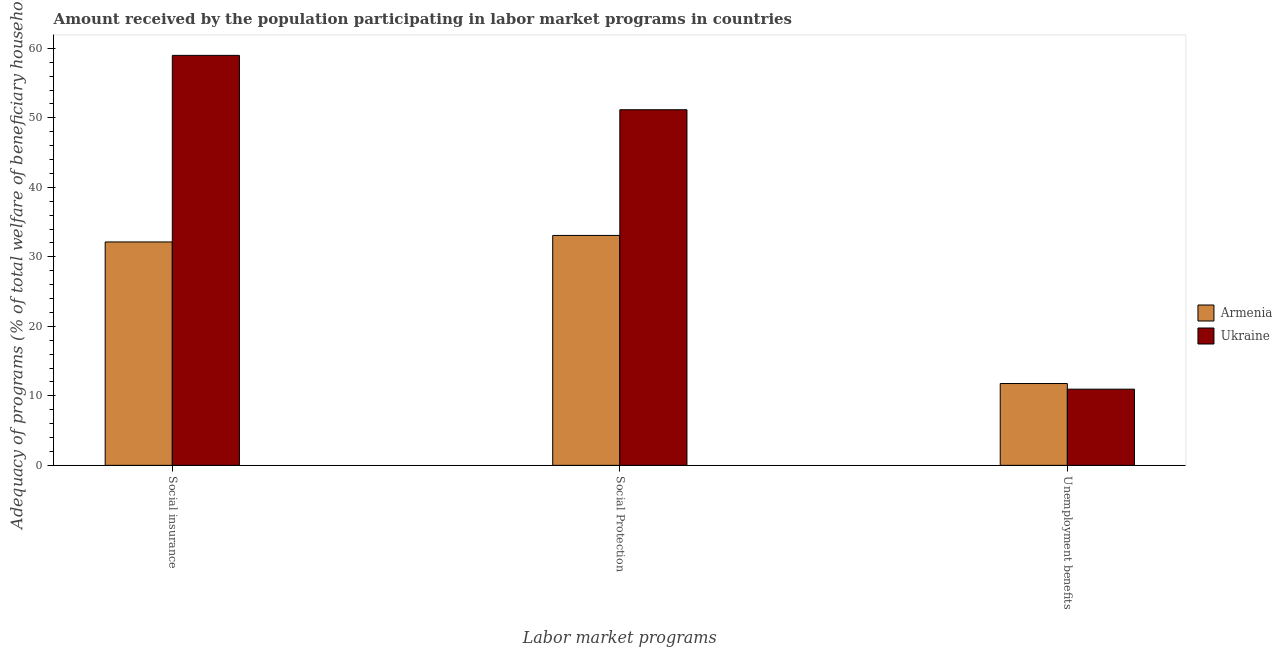How many different coloured bars are there?
Ensure brevity in your answer.  2. Are the number of bars per tick equal to the number of legend labels?
Your answer should be very brief. Yes. What is the label of the 2nd group of bars from the left?
Ensure brevity in your answer.  Social Protection. What is the amount received by the population participating in social protection programs in Armenia?
Make the answer very short. 33.08. Across all countries, what is the maximum amount received by the population participating in unemployment benefits programs?
Offer a terse response. 11.77. Across all countries, what is the minimum amount received by the population participating in social insurance programs?
Give a very brief answer. 32.15. In which country was the amount received by the population participating in social insurance programs maximum?
Your answer should be very brief. Ukraine. In which country was the amount received by the population participating in social insurance programs minimum?
Provide a short and direct response. Armenia. What is the total amount received by the population participating in social insurance programs in the graph?
Your answer should be compact. 91.14. What is the difference between the amount received by the population participating in social protection programs in Ukraine and that in Armenia?
Provide a succinct answer. 18.09. What is the difference between the amount received by the population participating in unemployment benefits programs in Ukraine and the amount received by the population participating in social insurance programs in Armenia?
Your answer should be very brief. -21.19. What is the average amount received by the population participating in unemployment benefits programs per country?
Ensure brevity in your answer.  11.37. What is the difference between the amount received by the population participating in social insurance programs and amount received by the population participating in social protection programs in Ukraine?
Offer a very short reply. 7.82. In how many countries, is the amount received by the population participating in social insurance programs greater than 18 %?
Make the answer very short. 2. What is the ratio of the amount received by the population participating in social protection programs in Armenia to that in Ukraine?
Your answer should be compact. 0.65. What is the difference between the highest and the second highest amount received by the population participating in unemployment benefits programs?
Provide a succinct answer. 0.81. What is the difference between the highest and the lowest amount received by the population participating in unemployment benefits programs?
Provide a short and direct response. 0.81. Is the sum of the amount received by the population participating in social insurance programs in Ukraine and Armenia greater than the maximum amount received by the population participating in unemployment benefits programs across all countries?
Make the answer very short. Yes. What does the 1st bar from the left in Social Protection represents?
Offer a very short reply. Armenia. What does the 2nd bar from the right in Social insurance represents?
Ensure brevity in your answer.  Armenia. Are all the bars in the graph horizontal?
Ensure brevity in your answer.  No. Are the values on the major ticks of Y-axis written in scientific E-notation?
Keep it short and to the point. No. How many legend labels are there?
Your answer should be very brief. 2. How are the legend labels stacked?
Your answer should be compact. Vertical. What is the title of the graph?
Give a very brief answer. Amount received by the population participating in labor market programs in countries. Does "Mozambique" appear as one of the legend labels in the graph?
Ensure brevity in your answer.  No. What is the label or title of the X-axis?
Your answer should be compact. Labor market programs. What is the label or title of the Y-axis?
Your answer should be very brief. Adequacy of programs (% of total welfare of beneficiary households). What is the Adequacy of programs (% of total welfare of beneficiary households) of Armenia in Social insurance?
Provide a succinct answer. 32.15. What is the Adequacy of programs (% of total welfare of beneficiary households) of Ukraine in Social insurance?
Your answer should be compact. 58.99. What is the Adequacy of programs (% of total welfare of beneficiary households) in Armenia in Social Protection?
Offer a very short reply. 33.08. What is the Adequacy of programs (% of total welfare of beneficiary households) in Ukraine in Social Protection?
Provide a succinct answer. 51.17. What is the Adequacy of programs (% of total welfare of beneficiary households) of Armenia in Unemployment benefits?
Ensure brevity in your answer.  11.77. What is the Adequacy of programs (% of total welfare of beneficiary households) of Ukraine in Unemployment benefits?
Give a very brief answer. 10.96. Across all Labor market programs, what is the maximum Adequacy of programs (% of total welfare of beneficiary households) in Armenia?
Provide a short and direct response. 33.08. Across all Labor market programs, what is the maximum Adequacy of programs (% of total welfare of beneficiary households) in Ukraine?
Your answer should be very brief. 58.99. Across all Labor market programs, what is the minimum Adequacy of programs (% of total welfare of beneficiary households) in Armenia?
Provide a short and direct response. 11.77. Across all Labor market programs, what is the minimum Adequacy of programs (% of total welfare of beneficiary households) in Ukraine?
Your response must be concise. 10.96. What is the total Adequacy of programs (% of total welfare of beneficiary households) in Armenia in the graph?
Ensure brevity in your answer.  77.01. What is the total Adequacy of programs (% of total welfare of beneficiary households) of Ukraine in the graph?
Offer a very short reply. 121.13. What is the difference between the Adequacy of programs (% of total welfare of beneficiary households) in Armenia in Social insurance and that in Social Protection?
Make the answer very short. -0.94. What is the difference between the Adequacy of programs (% of total welfare of beneficiary households) in Ukraine in Social insurance and that in Social Protection?
Ensure brevity in your answer.  7.82. What is the difference between the Adequacy of programs (% of total welfare of beneficiary households) of Armenia in Social insurance and that in Unemployment benefits?
Keep it short and to the point. 20.37. What is the difference between the Adequacy of programs (% of total welfare of beneficiary households) of Ukraine in Social insurance and that in Unemployment benefits?
Offer a terse response. 48.03. What is the difference between the Adequacy of programs (% of total welfare of beneficiary households) in Armenia in Social Protection and that in Unemployment benefits?
Offer a very short reply. 21.31. What is the difference between the Adequacy of programs (% of total welfare of beneficiary households) of Ukraine in Social Protection and that in Unemployment benefits?
Provide a succinct answer. 40.21. What is the difference between the Adequacy of programs (% of total welfare of beneficiary households) in Armenia in Social insurance and the Adequacy of programs (% of total welfare of beneficiary households) in Ukraine in Social Protection?
Provide a short and direct response. -19.02. What is the difference between the Adequacy of programs (% of total welfare of beneficiary households) of Armenia in Social insurance and the Adequacy of programs (% of total welfare of beneficiary households) of Ukraine in Unemployment benefits?
Offer a very short reply. 21.19. What is the difference between the Adequacy of programs (% of total welfare of beneficiary households) of Armenia in Social Protection and the Adequacy of programs (% of total welfare of beneficiary households) of Ukraine in Unemployment benefits?
Your answer should be very brief. 22.12. What is the average Adequacy of programs (% of total welfare of beneficiary households) of Armenia per Labor market programs?
Provide a succinct answer. 25.67. What is the average Adequacy of programs (% of total welfare of beneficiary households) in Ukraine per Labor market programs?
Give a very brief answer. 40.38. What is the difference between the Adequacy of programs (% of total welfare of beneficiary households) in Armenia and Adequacy of programs (% of total welfare of beneficiary households) in Ukraine in Social insurance?
Offer a very short reply. -26.85. What is the difference between the Adequacy of programs (% of total welfare of beneficiary households) of Armenia and Adequacy of programs (% of total welfare of beneficiary households) of Ukraine in Social Protection?
Provide a short and direct response. -18.09. What is the difference between the Adequacy of programs (% of total welfare of beneficiary households) of Armenia and Adequacy of programs (% of total welfare of beneficiary households) of Ukraine in Unemployment benefits?
Your answer should be compact. 0.81. What is the ratio of the Adequacy of programs (% of total welfare of beneficiary households) in Armenia in Social insurance to that in Social Protection?
Make the answer very short. 0.97. What is the ratio of the Adequacy of programs (% of total welfare of beneficiary households) of Ukraine in Social insurance to that in Social Protection?
Offer a very short reply. 1.15. What is the ratio of the Adequacy of programs (% of total welfare of beneficiary households) in Armenia in Social insurance to that in Unemployment benefits?
Provide a succinct answer. 2.73. What is the ratio of the Adequacy of programs (% of total welfare of beneficiary households) in Ukraine in Social insurance to that in Unemployment benefits?
Your response must be concise. 5.38. What is the ratio of the Adequacy of programs (% of total welfare of beneficiary households) in Armenia in Social Protection to that in Unemployment benefits?
Your answer should be compact. 2.81. What is the ratio of the Adequacy of programs (% of total welfare of beneficiary households) in Ukraine in Social Protection to that in Unemployment benefits?
Offer a terse response. 4.67. What is the difference between the highest and the second highest Adequacy of programs (% of total welfare of beneficiary households) in Armenia?
Offer a terse response. 0.94. What is the difference between the highest and the second highest Adequacy of programs (% of total welfare of beneficiary households) of Ukraine?
Offer a terse response. 7.82. What is the difference between the highest and the lowest Adequacy of programs (% of total welfare of beneficiary households) in Armenia?
Make the answer very short. 21.31. What is the difference between the highest and the lowest Adequacy of programs (% of total welfare of beneficiary households) of Ukraine?
Ensure brevity in your answer.  48.03. 